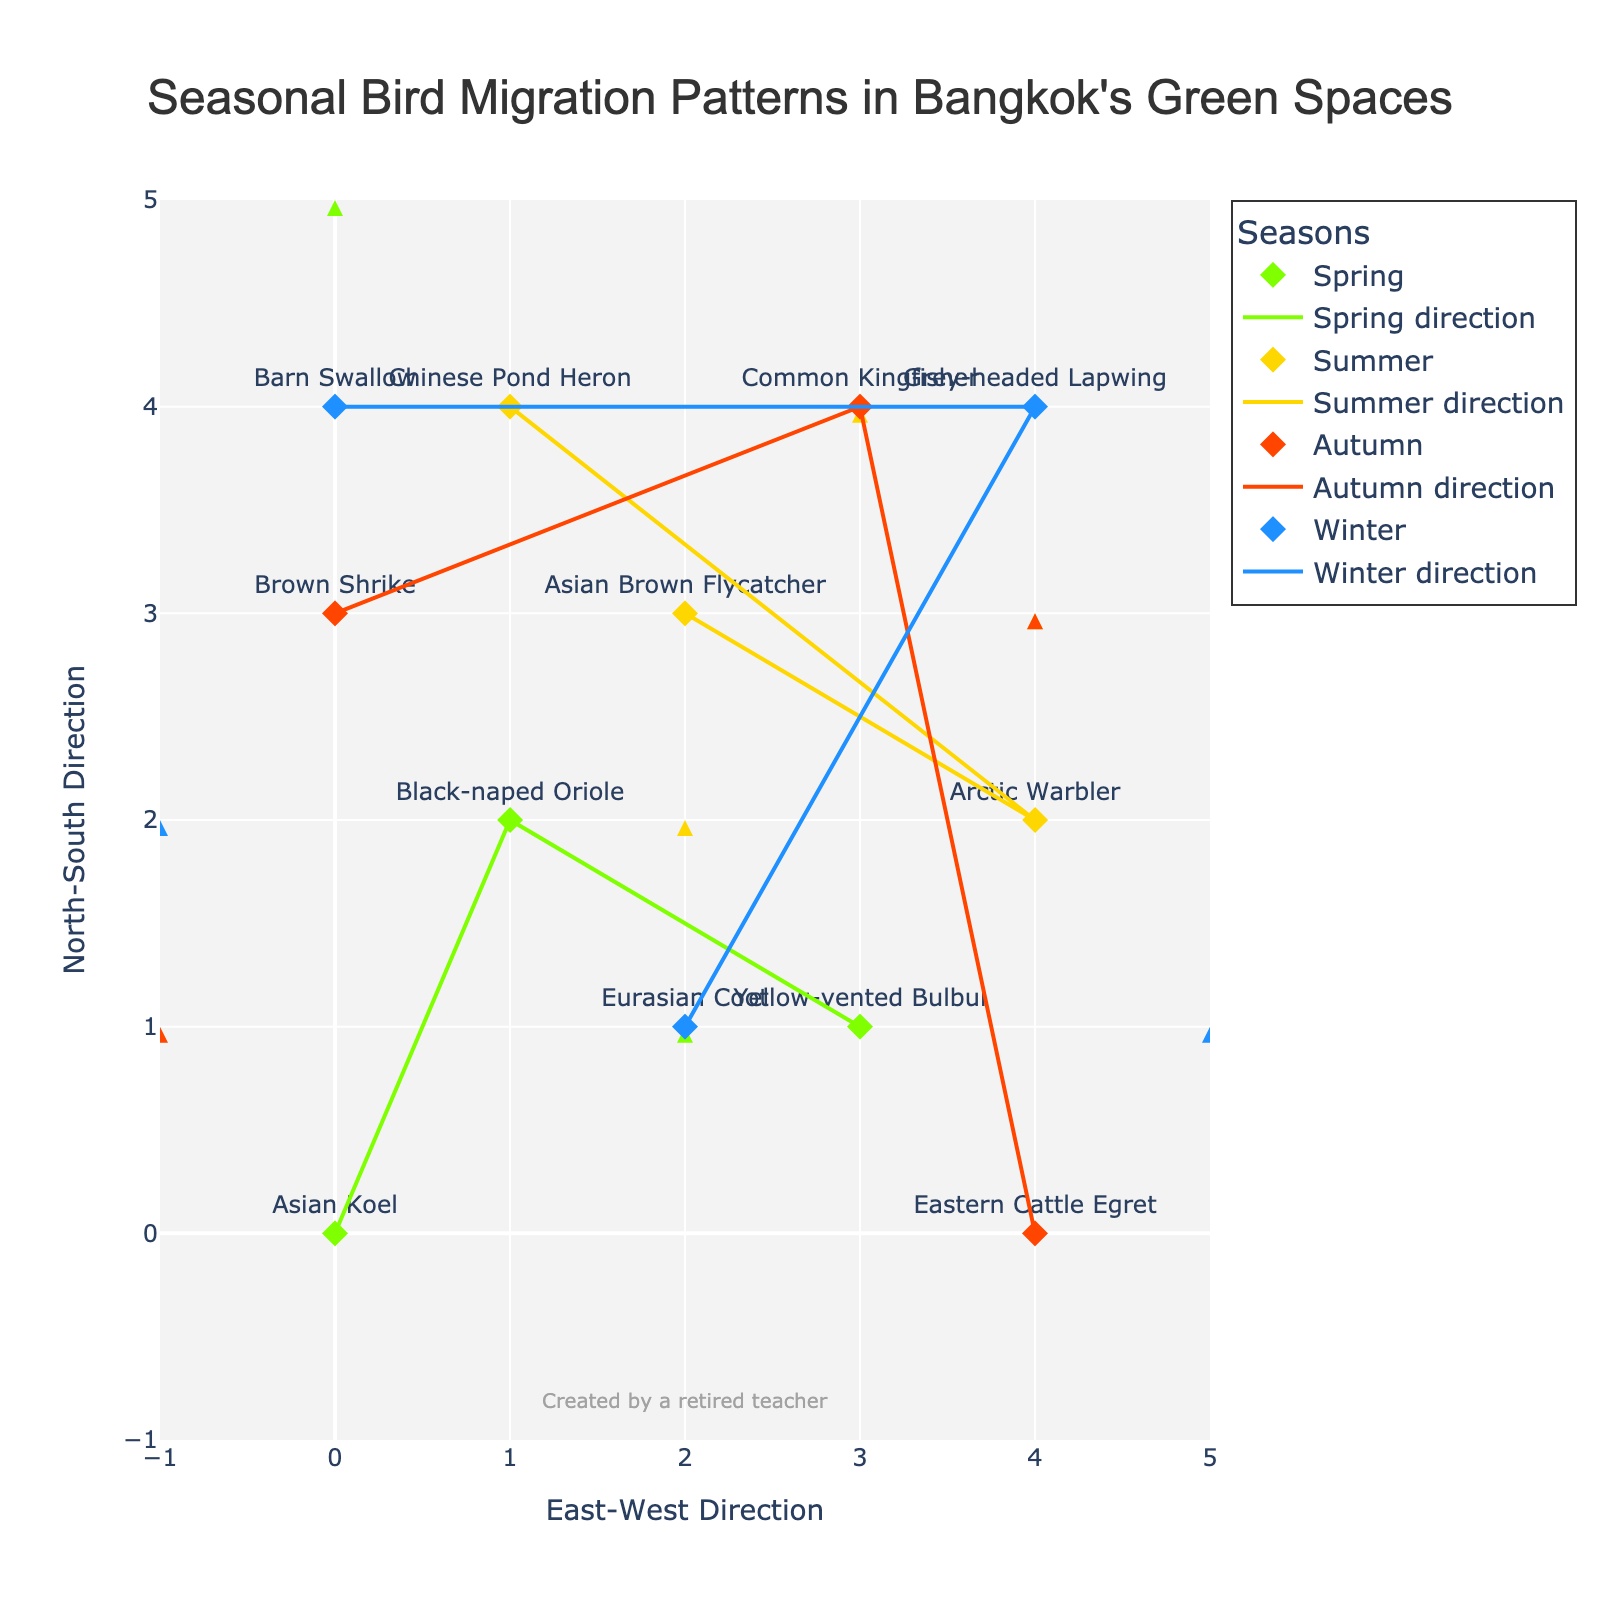What is the title of the plot? The title of the plot is centered at the top of the plot and given in a larger font size. It reads "Seasonal Bird Migration Patterns in Bangkok's Green Spaces".
Answer: Seasonal Bird Migration Patterns in Bangkok's Green Spaces How many bird species are plotted for each season? To answer this, count the different data points (represented by markers) for each season in the figure legend. There are four distinct colors representing the four seasons.
Answer: Spring: 3, Summer: 3, Autumn: 3, Winter: 3 Which season shows a bird moving the farthest north? By observing the direction vectors {u, v}, the farthest north a bird moves will have the largest positive v component value. Look for the highest endpoint in the "North-South Direction". A bird in Spring (specifically, the Black-naped Oriole) moves from (1, 2) to (0, 5).
Answer: Spring Which bird species moves the farthest in the East-West direction? Calculate the absolute value of the 'u' component for each bird species, as 'u' represents the movement in the East-West direction. The Chinese Pond Heron in Summer moves 3 units east to (4, 3).
Answer: Chinese Pond Heron How many bird species move southward during Winter? Southward movement is indicated by a negative 'v' value. Check each bird's {u, v} components during Winter. There are three species: Eurasian Coot {u=-3, v=1}, Grey-headed Lapwing {u=1, v=-3}, and Barn Swallow {u=-2, v=-1}. Only Grey-headed Lapwing and Barn Swallow move south.
Answer: 2 Which season has the most diverse directions of bird movement? To determine direction diversity, observe the variety in both 'u' and 'v' components for each season. Spring has birds moving in all directions: Northeast {Asian Koel}, South {Yellow-vented Bulbul}, and North {Black-naped Oriole}.
Answer: Spring What is the endpoint of the Arctic Warbler movement? The Arctic Warbler is observed in Summer, starting at (4,2) and moving with {u=-2, v=0}. Hence, the endpoint is calculated as (4-2, 2+0) = (2, 2).
Answer: (2, 2) Which bird in the plot moves directly north? Direct north movement means 'u' equals 0 and 'v' is positive. Check every bird’s {u, v} components. The Eastern Cattle Egret in Autumn has {u=0, v=3} at (4,0), moving directly north.
Answer: Eastern Cattle Egret 